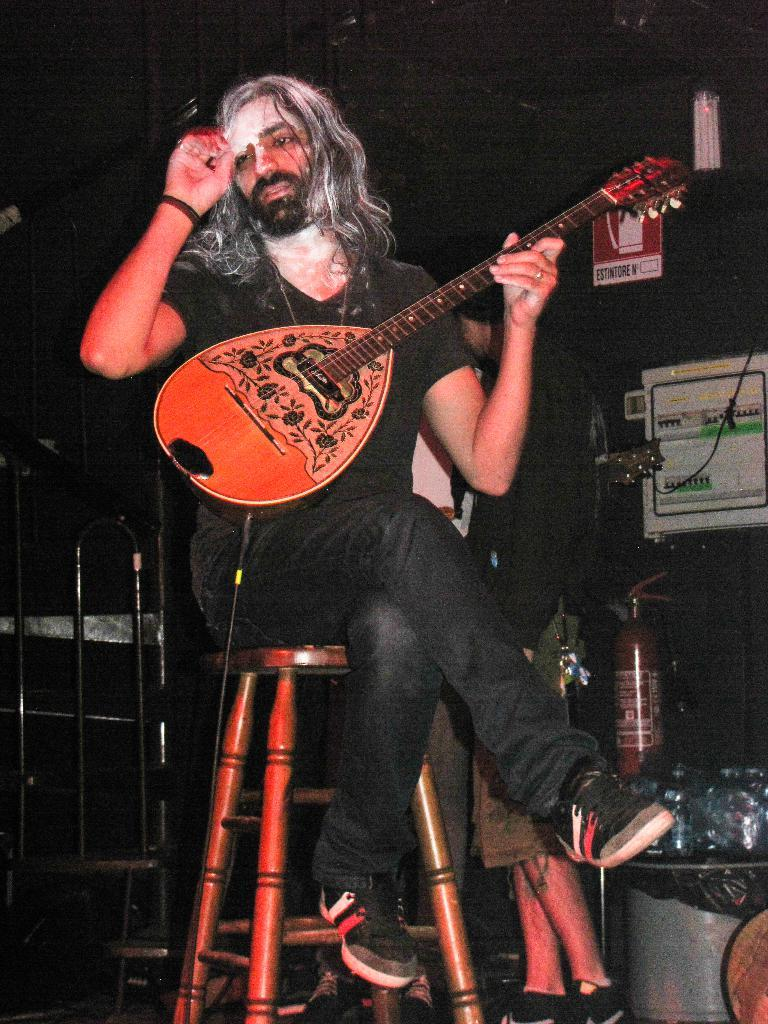Who is present in the image? There is a person in the image. What is the person wearing? The person is wearing a black dress. What is the person doing in the image? The person is sitting on a table and playing a guitar. What type of powder is visible on the person's collar in the image? There is no powder or collar visible on the person in the image; they are wearing a black dress. 